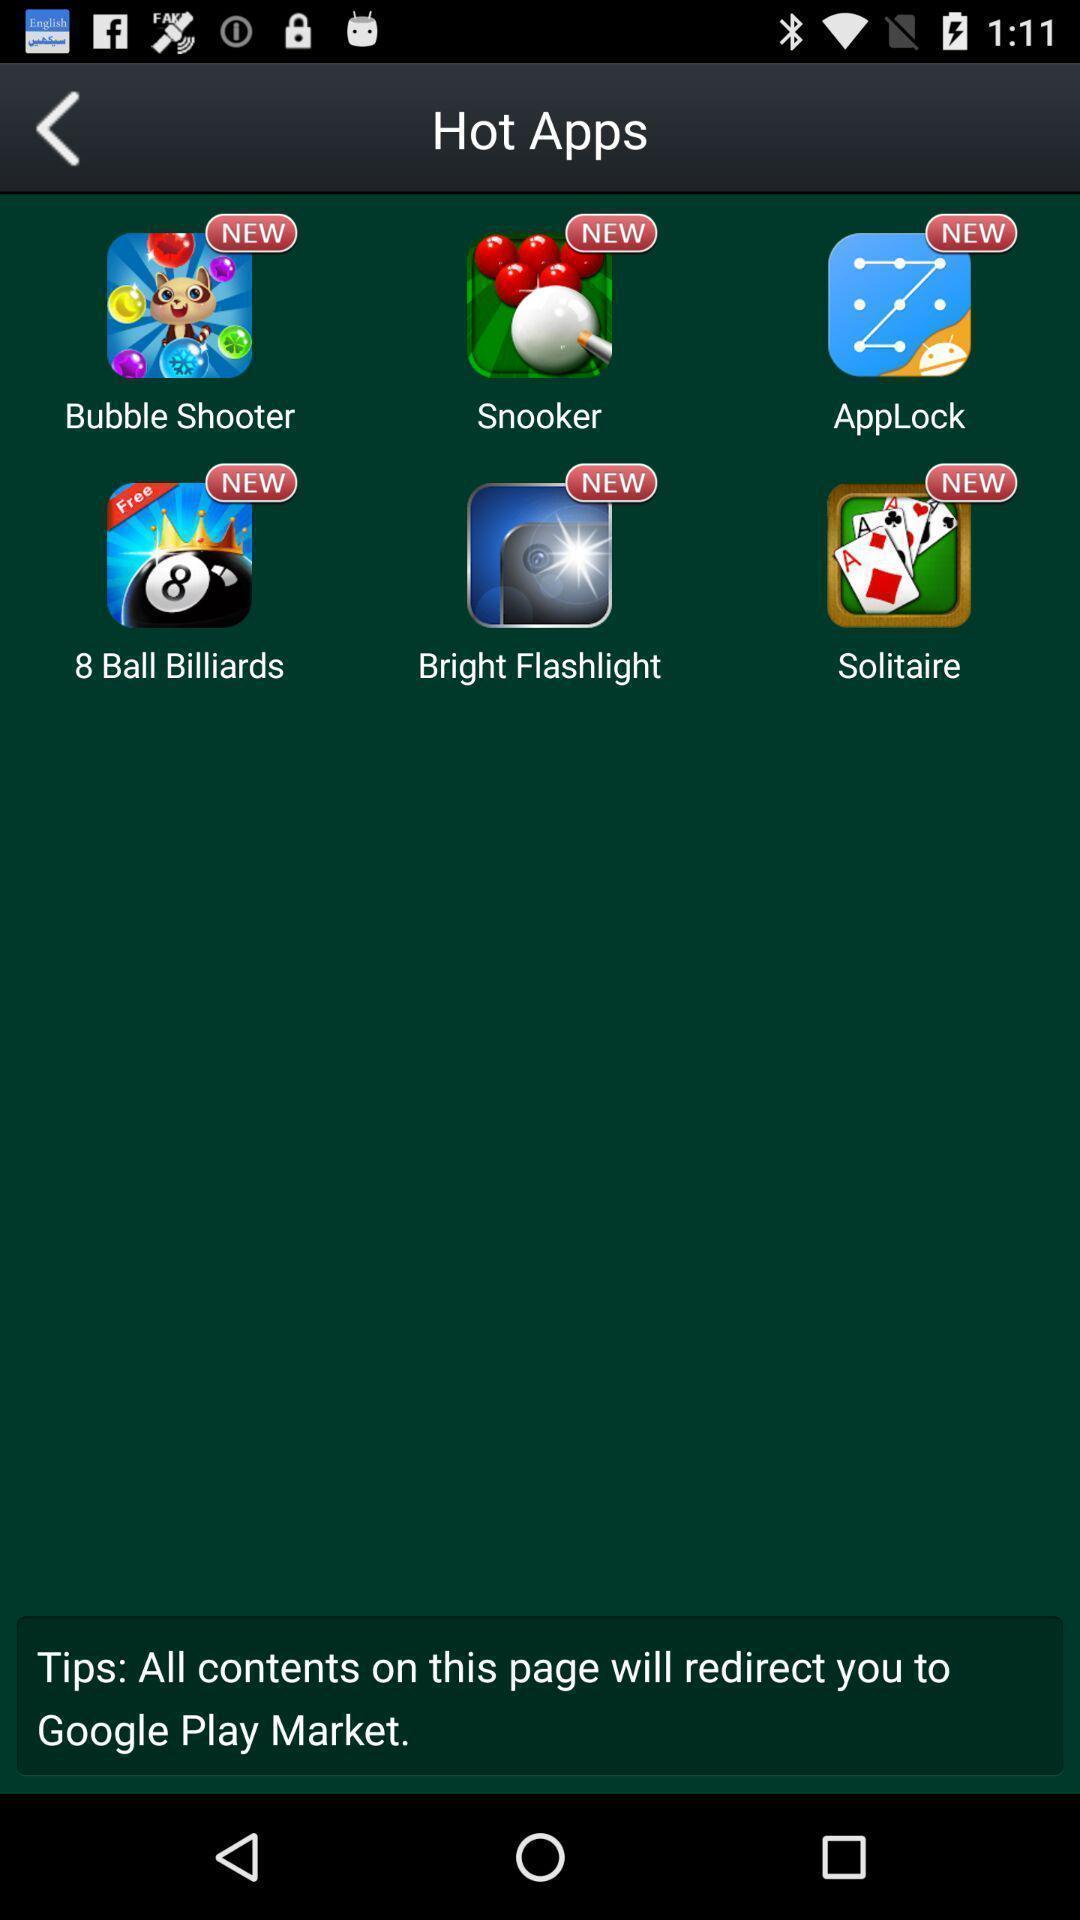Summarize the information in this screenshot. Screen displays different kind of applications. 